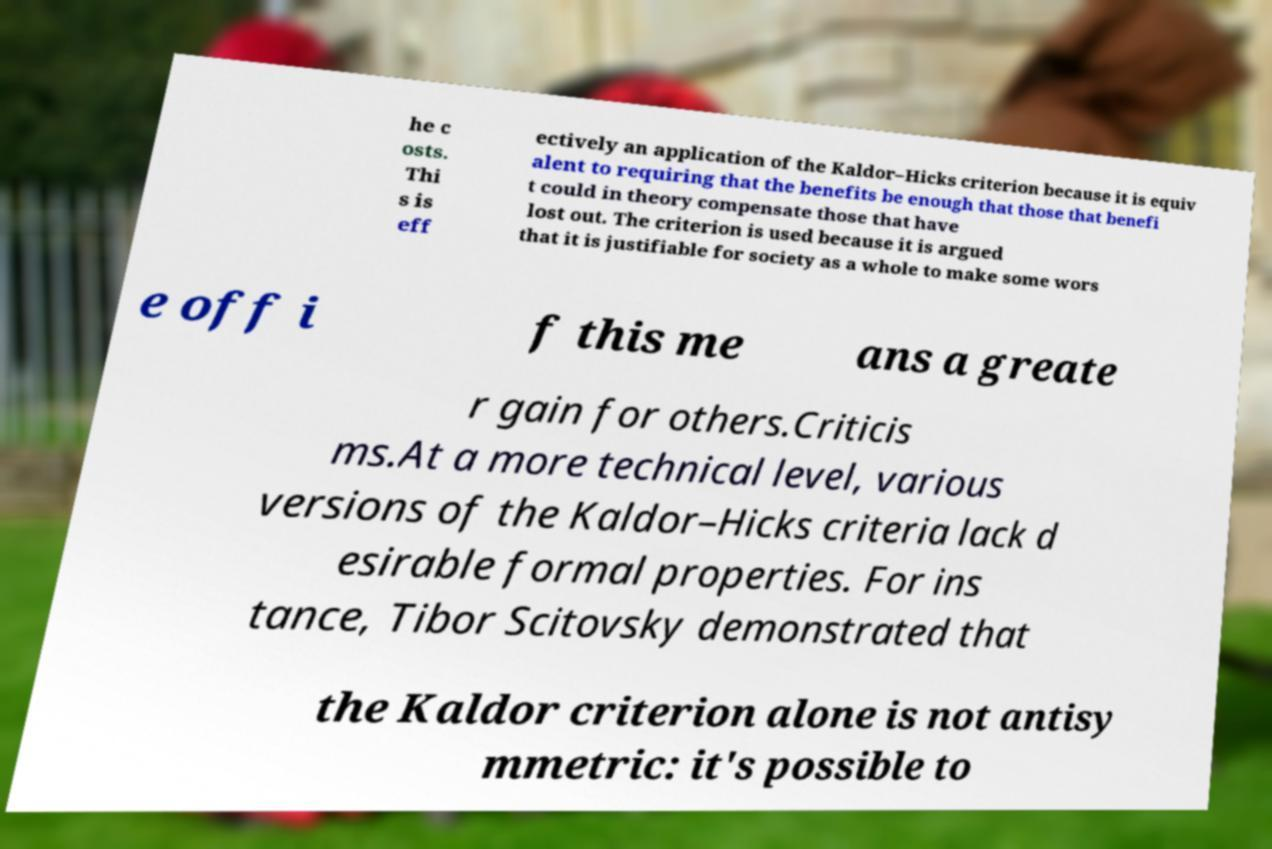Please read and relay the text visible in this image. What does it say? he c osts. Thi s is eff ectively an application of the Kaldor–Hicks criterion because it is equiv alent to requiring that the benefits be enough that those that benefi t could in theory compensate those that have lost out. The criterion is used because it is argued that it is justifiable for society as a whole to make some wors e off i f this me ans a greate r gain for others.Criticis ms.At a more technical level, various versions of the Kaldor–Hicks criteria lack d esirable formal properties. For ins tance, Tibor Scitovsky demonstrated that the Kaldor criterion alone is not antisy mmetric: it's possible to 